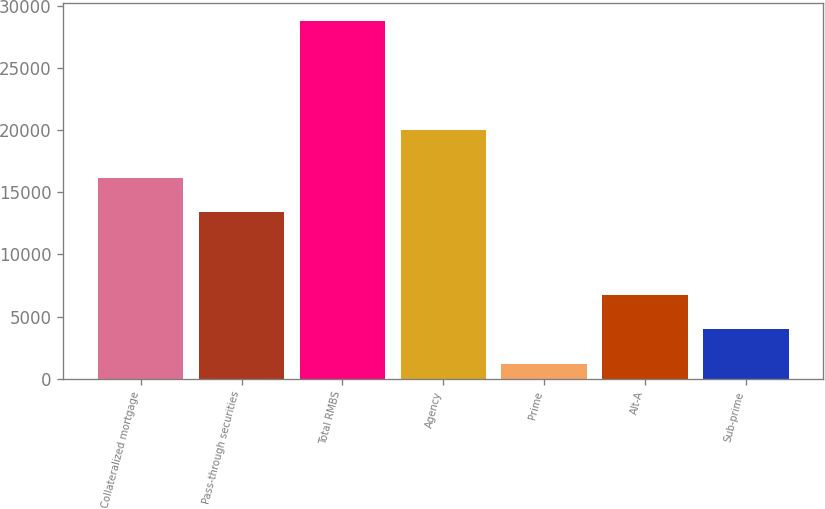<chart> <loc_0><loc_0><loc_500><loc_500><bar_chart><fcel>Collateralized mortgage<fcel>Pass-through securities<fcel>Total RMBS<fcel>Agency<fcel>Prime<fcel>Alt-A<fcel>Sub-prime<nl><fcel>16171.1<fcel>13412<fcel>28800<fcel>20010<fcel>1209<fcel>6727.2<fcel>3968.1<nl></chart> 